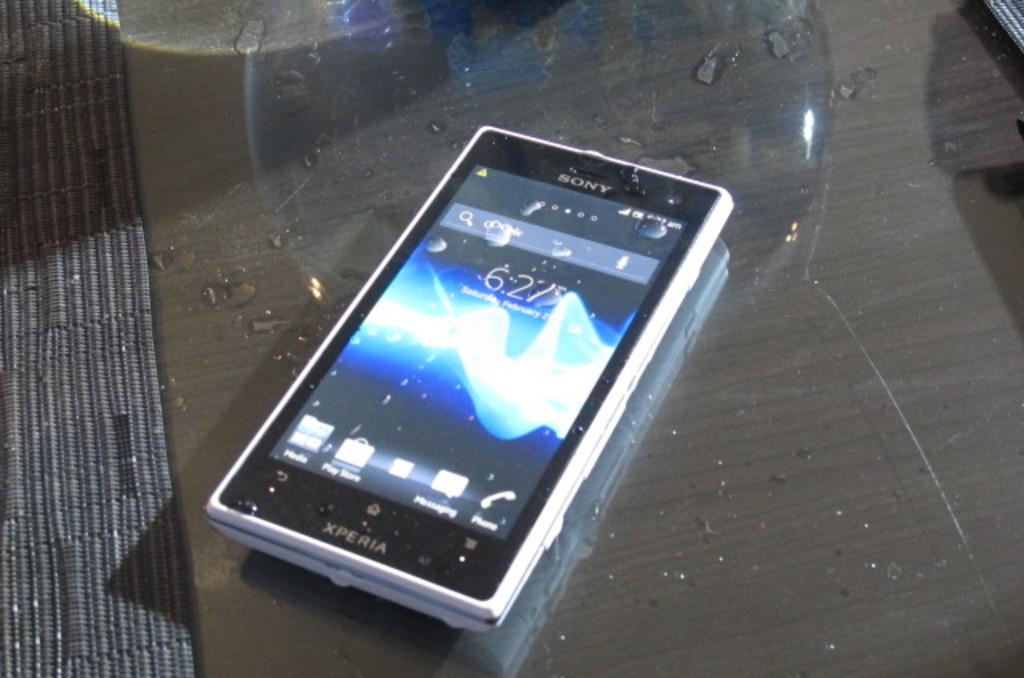What brand of phone is that?
Offer a very short reply. Sony. The brand is sony?
Ensure brevity in your answer.  Yes. 